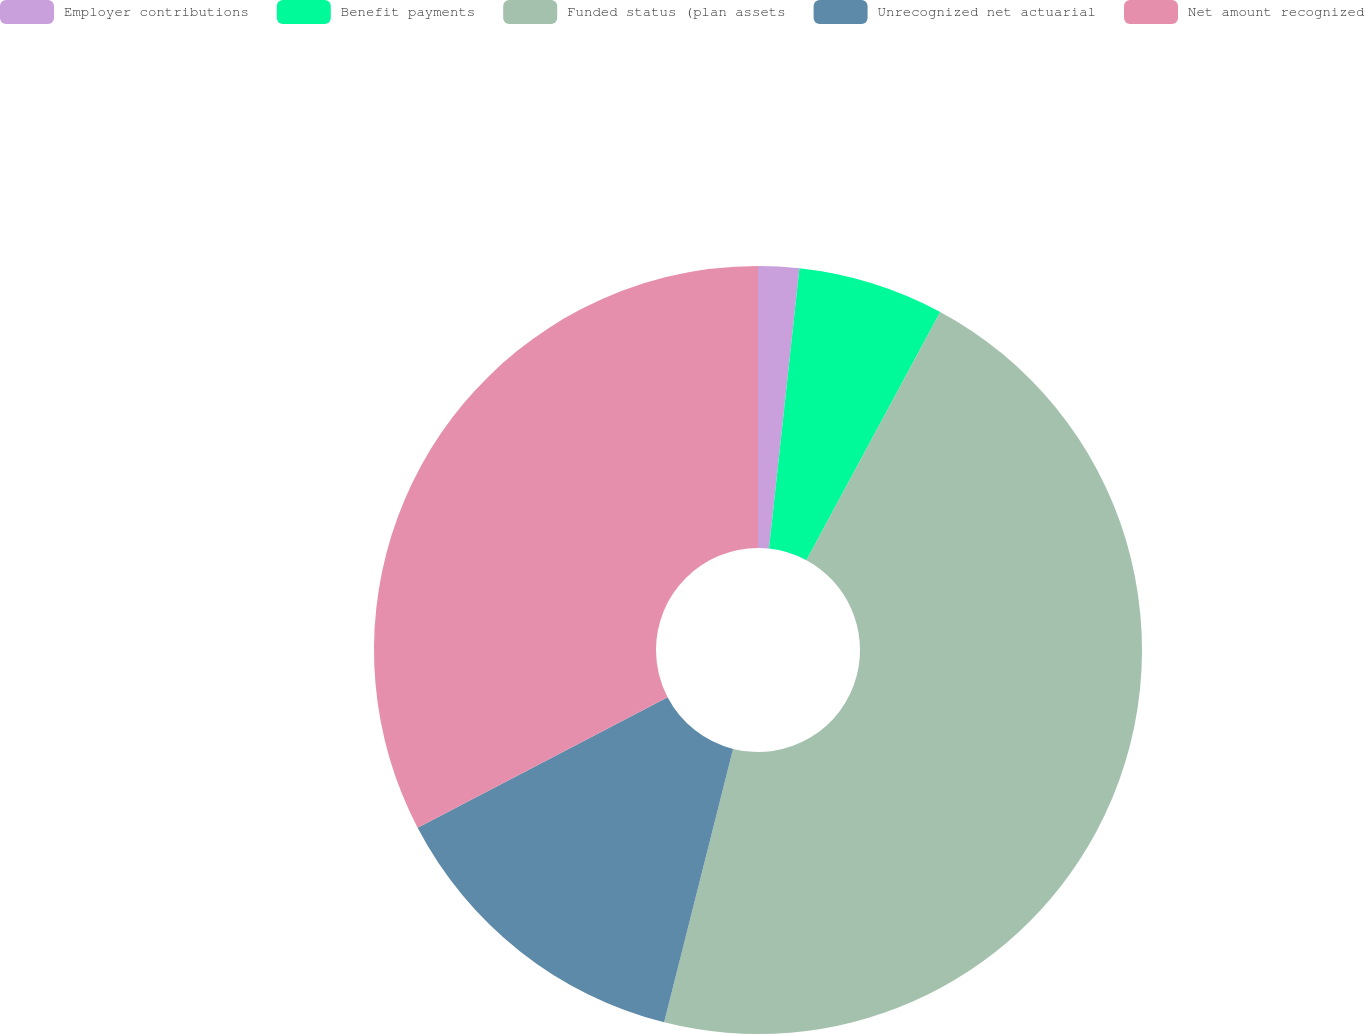<chart> <loc_0><loc_0><loc_500><loc_500><pie_chart><fcel>Employer contributions<fcel>Benefit payments<fcel>Funded status (plan assets<fcel>Unrecognized net actuarial<fcel>Net amount recognized<nl><fcel>1.72%<fcel>6.15%<fcel>46.06%<fcel>13.41%<fcel>32.66%<nl></chart> 